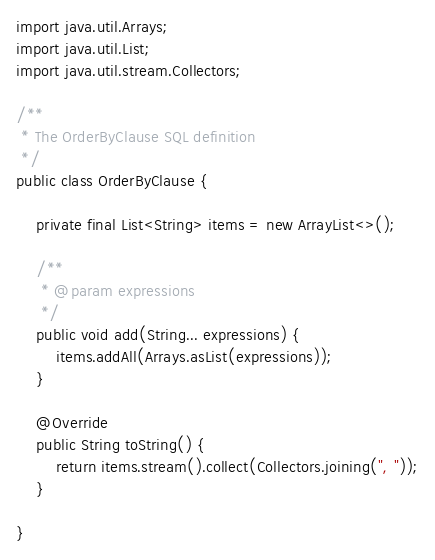Convert code to text. <code><loc_0><loc_0><loc_500><loc_500><_Java_>import java.util.Arrays;
import java.util.List;
import java.util.stream.Collectors;

/**
 * The OrderByClause SQL definition
 */
public class OrderByClause {

    private final List<String> items = new ArrayList<>();

    /**
     * @param expressions
     */
    public void add(String... expressions) {
        items.addAll(Arrays.asList(expressions));
    }

    @Override
    public String toString() {
        return items.stream().collect(Collectors.joining(", "));
    }

}
</code> 